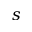<formula> <loc_0><loc_0><loc_500><loc_500>s</formula> 